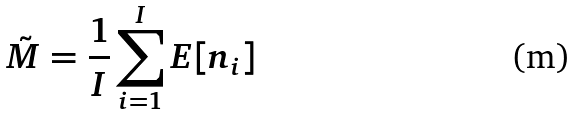Convert formula to latex. <formula><loc_0><loc_0><loc_500><loc_500>\tilde { M } = \frac { 1 } { I } \sum _ { i = 1 } ^ { I } E [ n _ { i } ]</formula> 